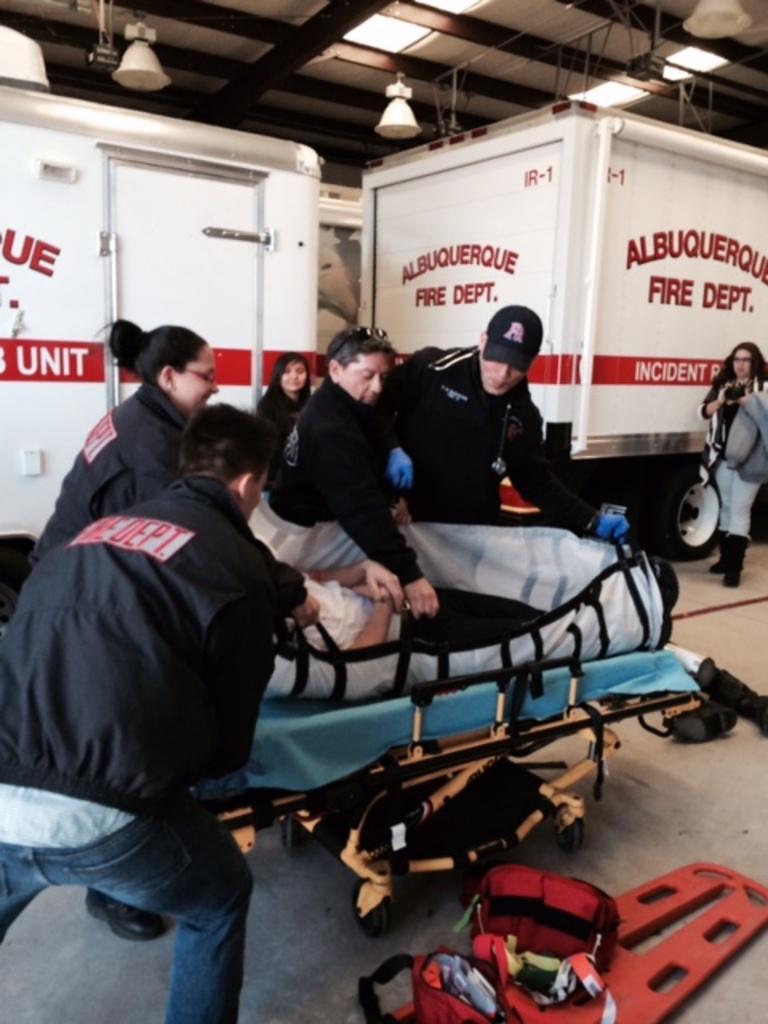Can you describe this image briefly? In this picture I can see some people were standing near to the bed. On that bed I can see small boy who is lying. At the bottom I can see the red colour object. On the right there is a woman who is standing near to the trucks. At the top I can see the lights. 